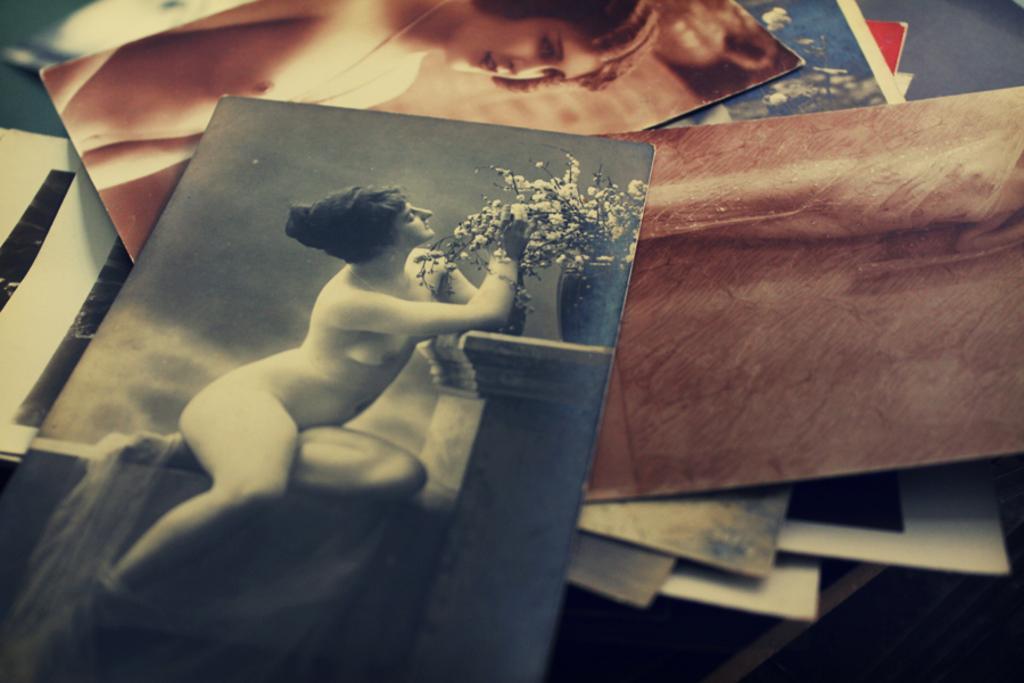Describe this image in one or two sentences. In this image we can see photographs placed on the table. 